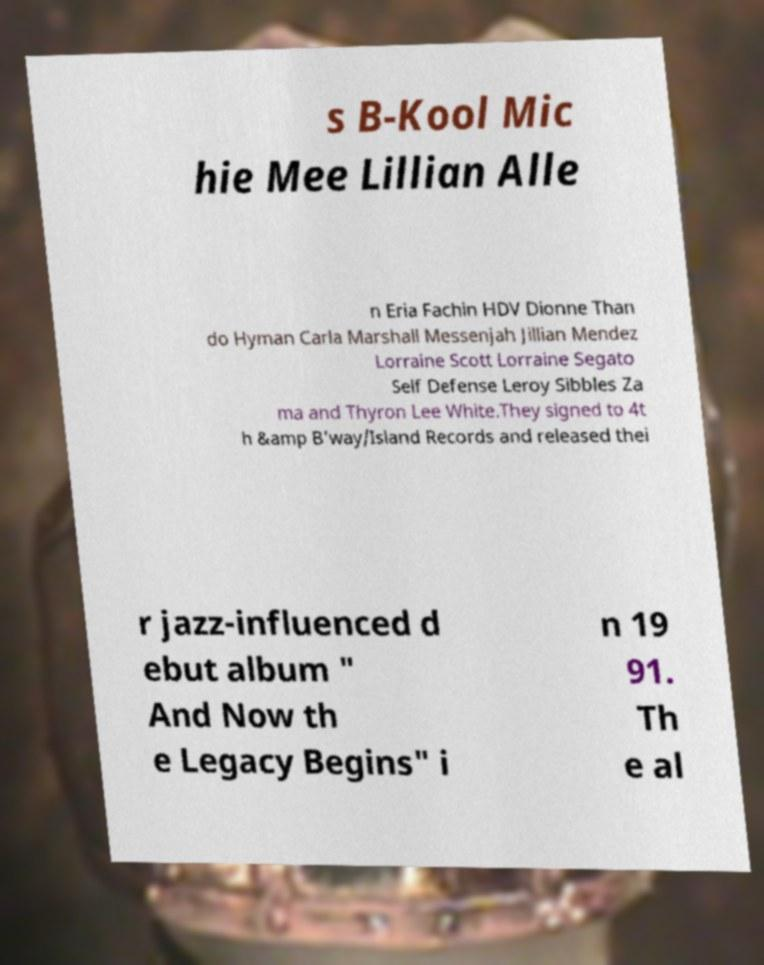I need the written content from this picture converted into text. Can you do that? s B-Kool Mic hie Mee Lillian Alle n Eria Fachin HDV Dionne Than do Hyman Carla Marshall Messenjah Jillian Mendez Lorraine Scott Lorraine Segato Self Defense Leroy Sibbles Za ma and Thyron Lee White.They signed to 4t h &amp B'way/Island Records and released thei r jazz-influenced d ebut album " And Now th e Legacy Begins" i n 19 91. Th e al 